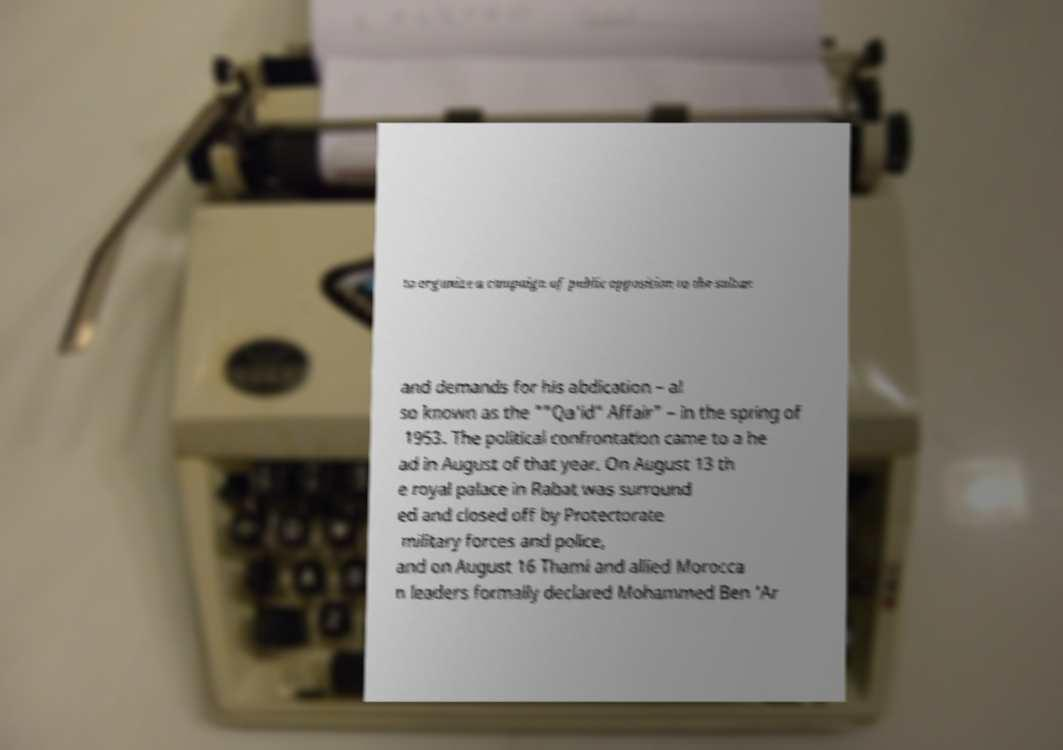Could you assist in decoding the text presented in this image and type it out clearly? to organize a campaign of public opposition to the sultan and demands for his abdication – al so known as the ""Qa'id" Affair" – in the spring of 1953. The political confrontation came to a he ad in August of that year. On August 13 th e royal palace in Rabat was surround ed and closed off by Protectorate military forces and police, and on August 16 Thami and allied Morocca n leaders formally declared Mohammed Ben 'Ar 